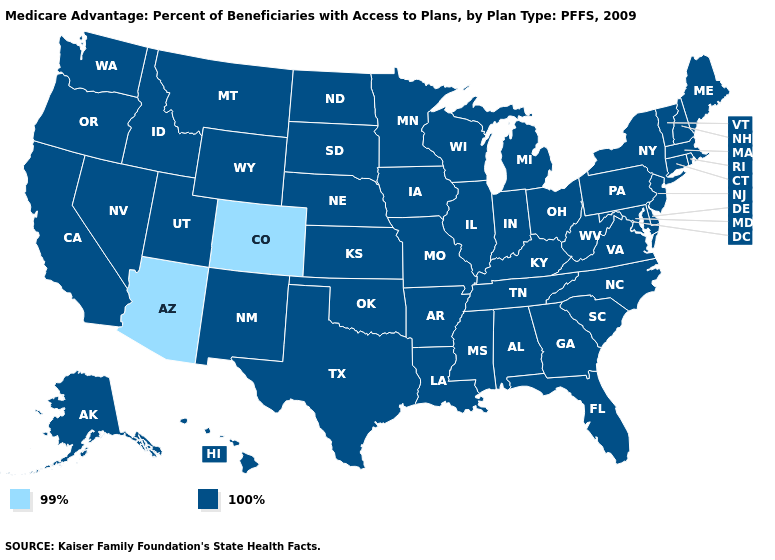Name the states that have a value in the range 99%?
Concise answer only. Arizona, Colorado. Name the states that have a value in the range 99%?
Give a very brief answer. Arizona, Colorado. Which states have the lowest value in the South?
Short answer required. Alabama, Arkansas, Delaware, Florida, Georgia, Kentucky, Louisiana, Maryland, Mississippi, North Carolina, Oklahoma, South Carolina, Tennessee, Texas, Virginia, West Virginia. What is the value of Alabama?
Quick response, please. 100%. Name the states that have a value in the range 100%?
Keep it brief. Alaska, Alabama, Arkansas, California, Connecticut, Delaware, Florida, Georgia, Hawaii, Iowa, Idaho, Illinois, Indiana, Kansas, Kentucky, Louisiana, Massachusetts, Maryland, Maine, Michigan, Minnesota, Missouri, Mississippi, Montana, North Carolina, North Dakota, Nebraska, New Hampshire, New Jersey, New Mexico, Nevada, New York, Ohio, Oklahoma, Oregon, Pennsylvania, Rhode Island, South Carolina, South Dakota, Tennessee, Texas, Utah, Virginia, Vermont, Washington, Wisconsin, West Virginia, Wyoming. What is the value of Alaska?
Quick response, please. 100%. What is the value of Washington?
Concise answer only. 100%. What is the value of North Dakota?
Give a very brief answer. 100%. Does the map have missing data?
Keep it brief. No. What is the value of Mississippi?
Keep it brief. 100%. What is the value of Massachusetts?
Keep it brief. 100%. What is the lowest value in the Northeast?
Keep it brief. 100%. What is the highest value in the MidWest ?
Answer briefly. 100%. Among the states that border Louisiana , which have the lowest value?
Short answer required. Arkansas, Mississippi, Texas. 